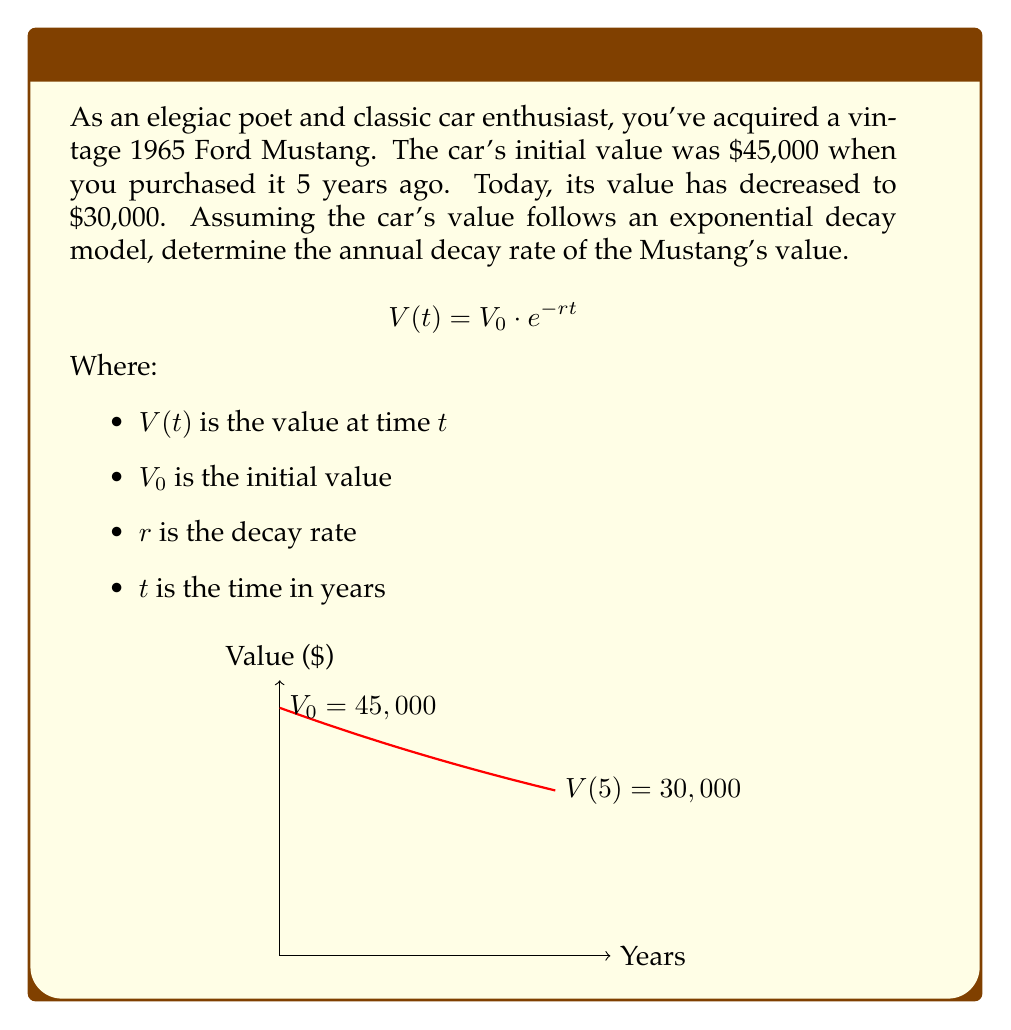Teach me how to tackle this problem. To solve this problem, we'll use the exponential decay formula and the given information:

1) Initial value $V_0 = 45,000$
2) Value after 5 years $V(5) = 30,000$
3) Time $t = 5$ years

Let's plug these into the formula:

$$30,000 = 45,000 \cdot e^{-5r}$$

Now, let's solve for $r$:

1) Divide both sides by 45,000:
   $$\frac{30,000}{45,000} = e^{-5r}$$

2) Simplify:
   $$\frac{2}{3} = e^{-5r}$$

3) Take the natural logarithm of both sides:
   $$\ln(\frac{2}{3}) = \ln(e^{-5r})$$

4) Simplify the right side using logarithm properties:
   $$\ln(\frac{2}{3}) = -5r$$

5) Divide both sides by -5:
   $$\frac{\ln(\frac{2}{3})}{-5} = r$$

6) Calculate the value:
   $$r \approx 0.0811 \text{ or } 8.11\%$$

Therefore, the annual decay rate of the Mustang's value is approximately 8.11%.
Answer: $r \approx 0.0811$ or $8.11\%$ 